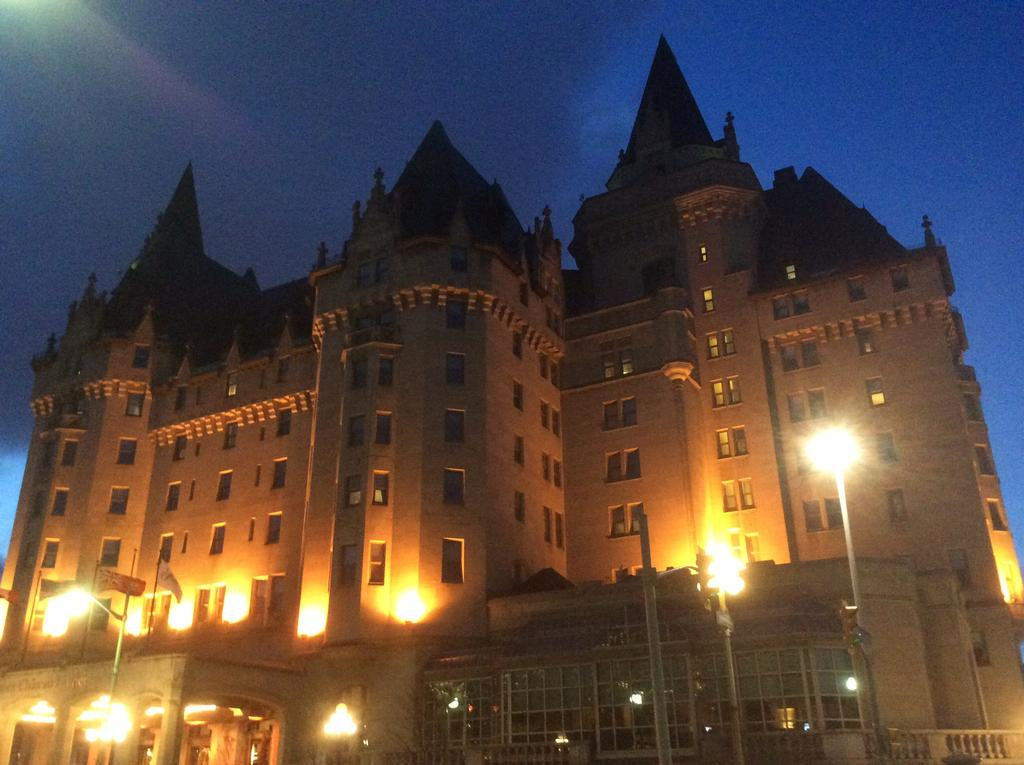What is the main structure in the image? There is a castle in the image. What architectural feature can be seen on the castle? The castle has many windows. What is illuminating the front of the castle? There are lights in the front of the castle. What can be seen above the castle in the image? The sky is visible above the castle. What is the purpose of the body in the image? There is no body present in the image; it features a castle with lights and windows. What form does the castle take in the image? The castle in the image appears to be a traditional, multi-story structure with many windows and lights. 